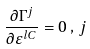<formula> <loc_0><loc_0><loc_500><loc_500>\frac { \partial \Gamma ^ { j } } { \partial \varepsilon ^ { l C } } = 0 \, , \, j</formula> 